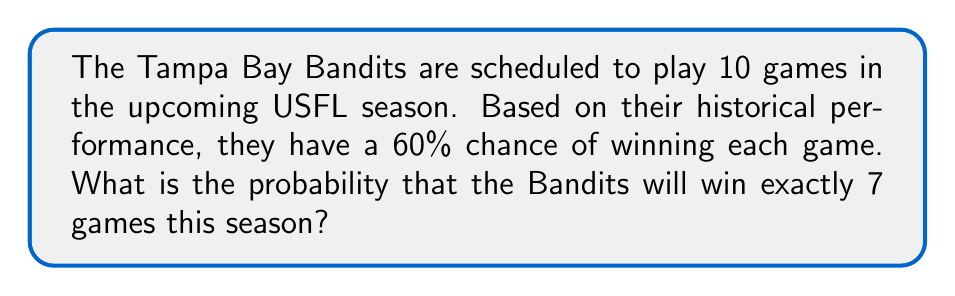Show me your answer to this math problem. To solve this problem, we need to use the binomial probability formula. The binomial distribution is used when we have a fixed number of independent trials (games), each with the same probability of success (winning).

Let's define our variables:
$n = 10$ (total number of games)
$k = 7$ (number of wins we're interested in)
$p = 0.60$ (probability of winning each game)
$q = 1 - p = 0.40$ (probability of losing each game)

The binomial probability formula is:

$$ P(X = k) = \binom{n}{k} p^k q^{n-k} $$

Where $\binom{n}{k}$ is the binomial coefficient, calculated as:

$$ \binom{n}{k} = \frac{n!}{k!(n-k)!} $$

Let's solve step by step:

1) Calculate the binomial coefficient:
   $$ \binom{10}{7} = \frac{10!}{7!(10-7)!} = \frac{10!}{7!3!} = 120 $$

2) Apply the binomial probability formula:
   $$ P(X = 7) = 120 \cdot (0.60)^7 \cdot (0.40)^{10-7} $$
   $$ = 120 \cdot (0.60)^7 \cdot (0.40)^3 $$

3) Calculate the result:
   $$ = 120 \cdot 0.0279936 \cdot 0.064 $$
   $$ = 0.2150707 $$

4) Round to four decimal places:
   $$ \approx 0.2151 $$

Therefore, the probability of the Tampa Bay Bandits winning exactly 7 games in a 10-game season, given a 60% chance of winning each game, is approximately 0.2151 or 21.51%.
Answer: 0.2151 or 21.51% 